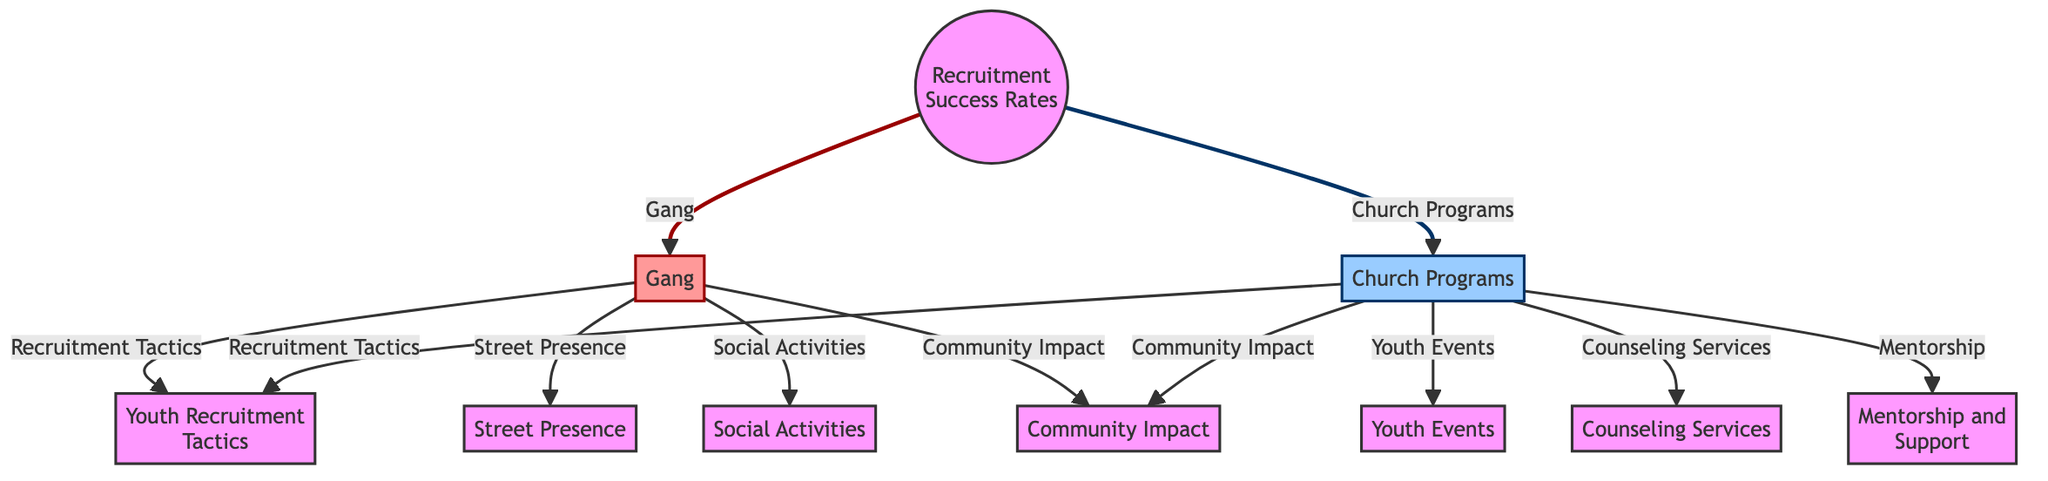What are the two main categories of recruitment discussed in the diagram? The diagram presents two main categories: "Gang" and "Church Programs" at the top level. These represent the two distinct approaches to youth recruitment that are being compared.
Answer: Gang, Church Programs How many recruitment tactics are listed in the diagram? The diagram shows a total of 2 recruitment tactics, namely "Youth Recruitment Tactics," which connects to both "Gang" and "Church Programs."
Answer: 2 Which program focuses on "Counseling Services"? The "Counseling Services" node is connected to the "Church Programs," indicating that this service is specifically offered within the church initiatives aimed at youth.
Answer: Church Programs What two features does the "Gang" have that the "Church Programs" do not? The "Gang" is associated with "Street Presence" and "Social Activities," which are not directly listed under "Church Programs," reflecting the distinct methods employed by each group for engagement.
Answer: Street Presence, Social Activities Which program emphasizes "Mentorship and Support"? The diagram indicates that "Mentorship and Support" is a feature of the "Church Programs," highlighting its focus on providing guidance and assistance to youth within its initiatives.
Answer: Church Programs How many nodes are connected to "Community Impact"? There are 2 nodes connected to "Community Impact," which are "Gang" and "Church Programs," signifying that both approaches aim to have a societal effect.
Answer: 2 What is the relationship between "Youth Events" and "Church Programs"? "Youth Events" is directly linked to "Church Programs," indicating that the church organizes specific events targeting the youth for engagement.
Answer: Youth Events Which two types of activities are grouped under "Youth Recruitment Tactics"? The activities grouped under "Youth Recruitment Tactics" include “Mentorship and Support” and “Counseling Services.” These activities depict the strategies employed for attracting youth by the church.
Answer: Mentorship and Support, Counseling Services 